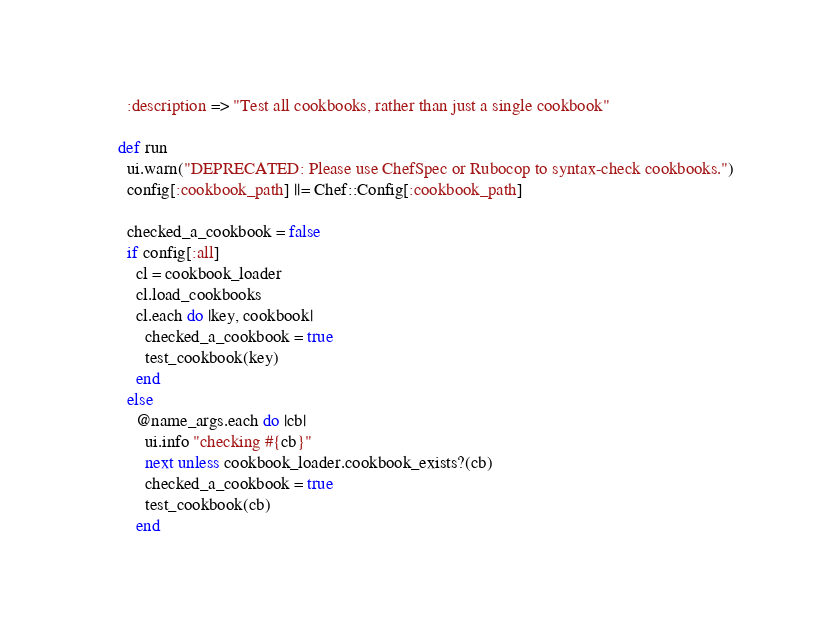Convert code to text. <code><loc_0><loc_0><loc_500><loc_500><_Ruby_>        :description => "Test all cookbooks, rather than just a single cookbook"

      def run
        ui.warn("DEPRECATED: Please use ChefSpec or Rubocop to syntax-check cookbooks.")
        config[:cookbook_path] ||= Chef::Config[:cookbook_path]

        checked_a_cookbook = false
        if config[:all]
          cl = cookbook_loader
          cl.load_cookbooks
          cl.each do |key, cookbook|
            checked_a_cookbook = true
            test_cookbook(key)
          end
        else
          @name_args.each do |cb|
            ui.info "checking #{cb}"
            next unless cookbook_loader.cookbook_exists?(cb)
            checked_a_cookbook = true
            test_cookbook(cb)
          end</code> 